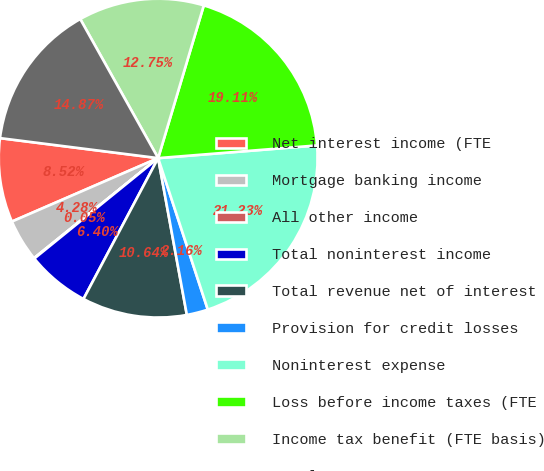<chart> <loc_0><loc_0><loc_500><loc_500><pie_chart><fcel>Net interest income (FTE<fcel>Mortgage banking income<fcel>All other income<fcel>Total noninterest income<fcel>Total revenue net of interest<fcel>Provision for credit losses<fcel>Noninterest expense<fcel>Loss before income taxes (FTE<fcel>Income tax benefit (FTE basis)<fcel>Net loss<nl><fcel>8.52%<fcel>4.28%<fcel>0.05%<fcel>6.4%<fcel>10.64%<fcel>2.16%<fcel>21.23%<fcel>19.11%<fcel>12.75%<fcel>14.87%<nl></chart> 